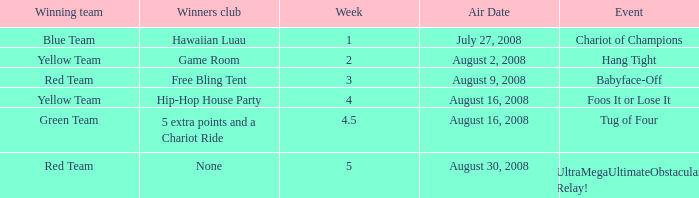Which Winners club has a Week of 4.5? 5 extra points and a Chariot Ride. 